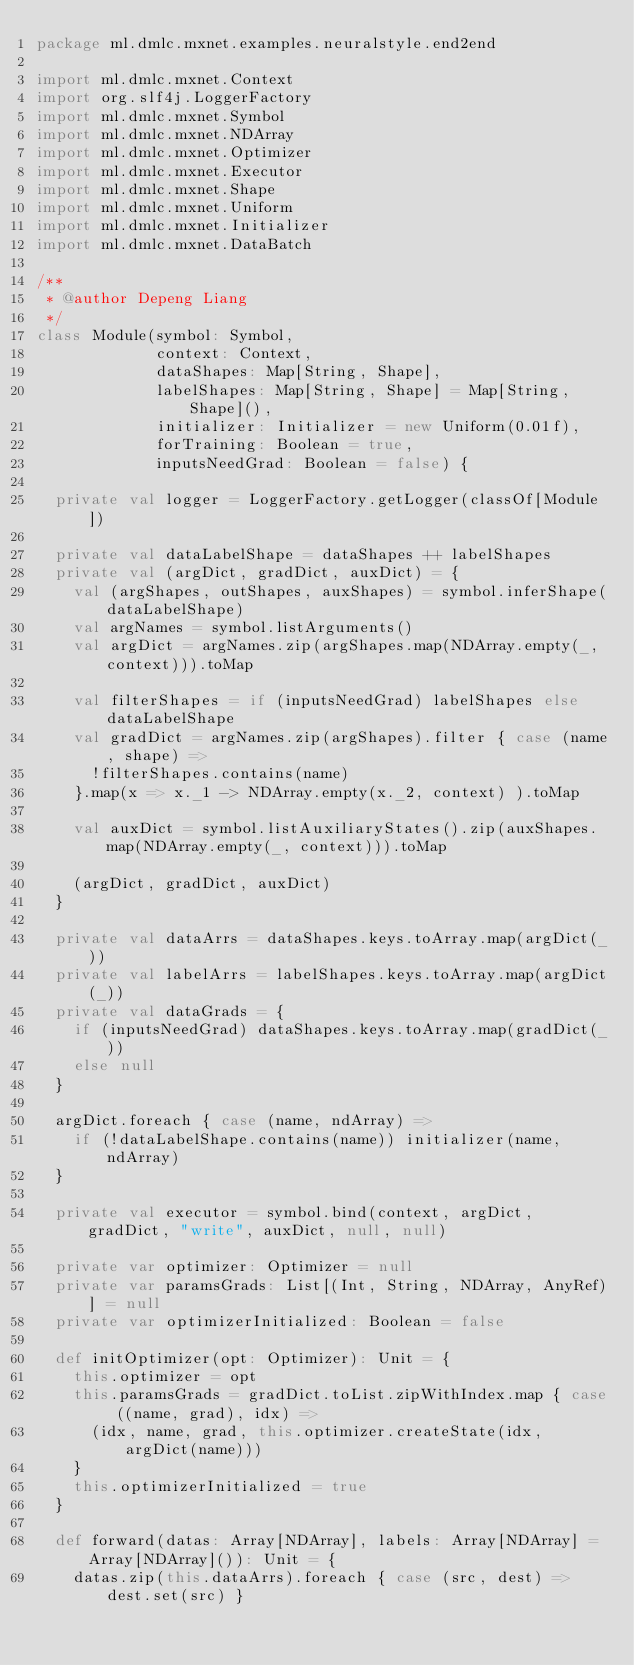<code> <loc_0><loc_0><loc_500><loc_500><_Scala_>package ml.dmlc.mxnet.examples.neuralstyle.end2end

import ml.dmlc.mxnet.Context
import org.slf4j.LoggerFactory
import ml.dmlc.mxnet.Symbol
import ml.dmlc.mxnet.NDArray
import ml.dmlc.mxnet.Optimizer
import ml.dmlc.mxnet.Executor
import ml.dmlc.mxnet.Shape
import ml.dmlc.mxnet.Uniform
import ml.dmlc.mxnet.Initializer
import ml.dmlc.mxnet.DataBatch

/**
 * @author Depeng Liang
 */
class Module(symbol: Symbol,
             context: Context,
             dataShapes: Map[String, Shape],
             labelShapes: Map[String, Shape] = Map[String, Shape](),
             initializer: Initializer = new Uniform(0.01f),
             forTraining: Boolean = true,
             inputsNeedGrad: Boolean = false) {

  private val logger = LoggerFactory.getLogger(classOf[Module])

  private val dataLabelShape = dataShapes ++ labelShapes
  private val (argDict, gradDict, auxDict) = {
    val (argShapes, outShapes, auxShapes) = symbol.inferShape(dataLabelShape)
    val argNames = symbol.listArguments()
    val argDict = argNames.zip(argShapes.map(NDArray.empty(_, context))).toMap

    val filterShapes = if (inputsNeedGrad) labelShapes else dataLabelShape
    val gradDict = argNames.zip(argShapes).filter { case (name, shape) =>
      !filterShapes.contains(name)
    }.map(x => x._1 -> NDArray.empty(x._2, context) ).toMap

    val auxDict = symbol.listAuxiliaryStates().zip(auxShapes.map(NDArray.empty(_, context))).toMap

    (argDict, gradDict, auxDict)
  }

  private val dataArrs = dataShapes.keys.toArray.map(argDict(_))
  private val labelArrs = labelShapes.keys.toArray.map(argDict(_))
  private val dataGrads = {
    if (inputsNeedGrad) dataShapes.keys.toArray.map(gradDict(_))
    else null
  }

  argDict.foreach { case (name, ndArray) =>
    if (!dataLabelShape.contains(name)) initializer(name, ndArray)
  }

  private val executor = symbol.bind(context, argDict, gradDict, "write", auxDict, null, null)

  private var optimizer: Optimizer = null
  private var paramsGrads: List[(Int, String, NDArray, AnyRef)] = null
  private var optimizerInitialized: Boolean = false

  def initOptimizer(opt: Optimizer): Unit = {
    this.optimizer = opt
    this.paramsGrads = gradDict.toList.zipWithIndex.map { case ((name, grad), idx) =>
      (idx, name, grad, this.optimizer.createState(idx, argDict(name)))
    }
    this.optimizerInitialized = true
  }

  def forward(datas: Array[NDArray], labels: Array[NDArray] = Array[NDArray]()): Unit = {
    datas.zip(this.dataArrs).foreach { case (src, dest) => dest.set(src) }</code> 